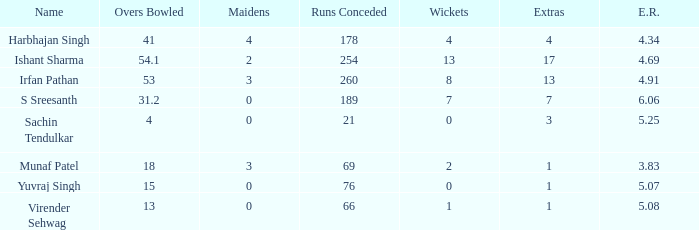Name the maaidens where overs bowled is 13 0.0. 